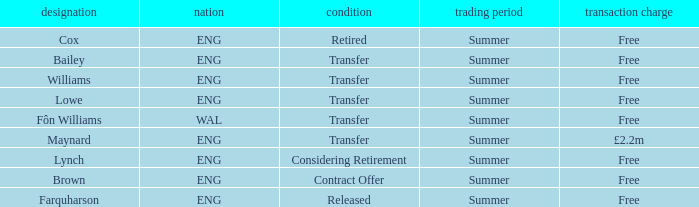What is the status of the Eng Country from the Maynard name? Transfer. 